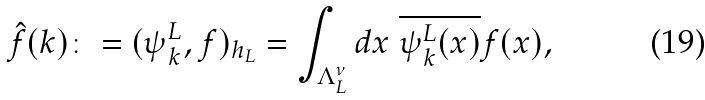Convert formula to latex. <formula><loc_0><loc_0><loc_500><loc_500>\hat { f } ( k ) \colon = ( \psi _ { k } ^ { L } , f ) _ { h _ { L } } = \int _ { \Lambda _ { L } ^ { \nu } } d x \ \overline { \psi _ { k } ^ { L } ( x ) } f ( x ) ,</formula> 